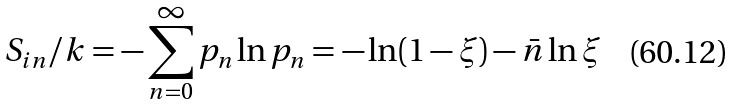Convert formula to latex. <formula><loc_0><loc_0><loc_500><loc_500>S _ { i n } / k = - \sum _ { n = 0 } ^ { \infty } p _ { n } \ln p _ { n } = - \ln ( 1 - \xi ) - \bar { n } \ln \xi</formula> 